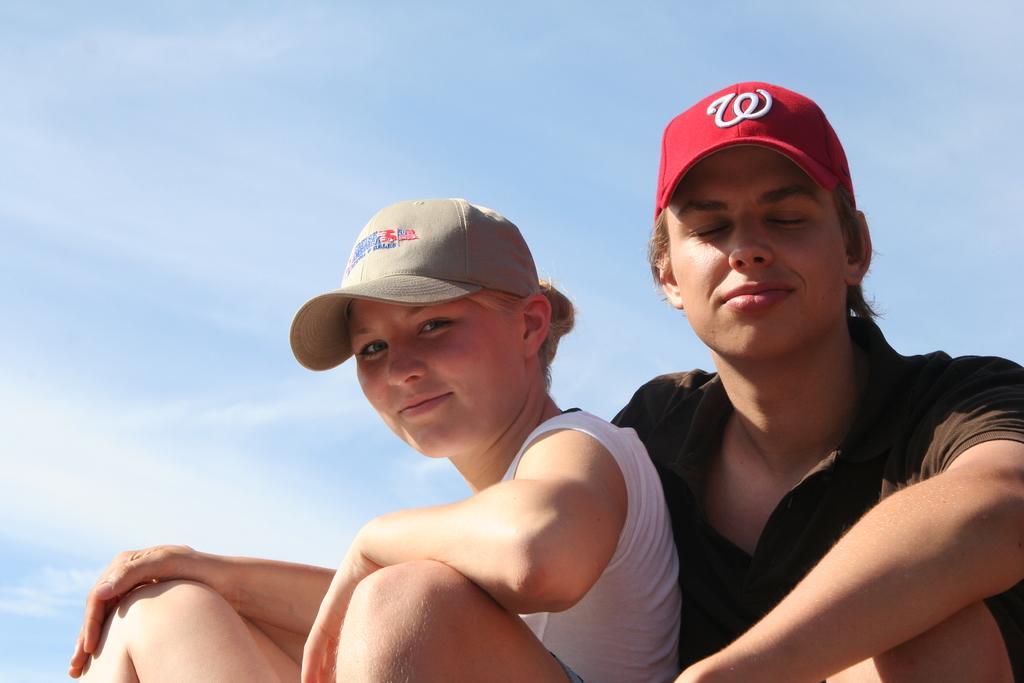Describe this image in one or two sentences. In this image I can see two people with different color dresses. I can see these people are also wearing the caps. In the background I can see the clouds and the blue sky. 